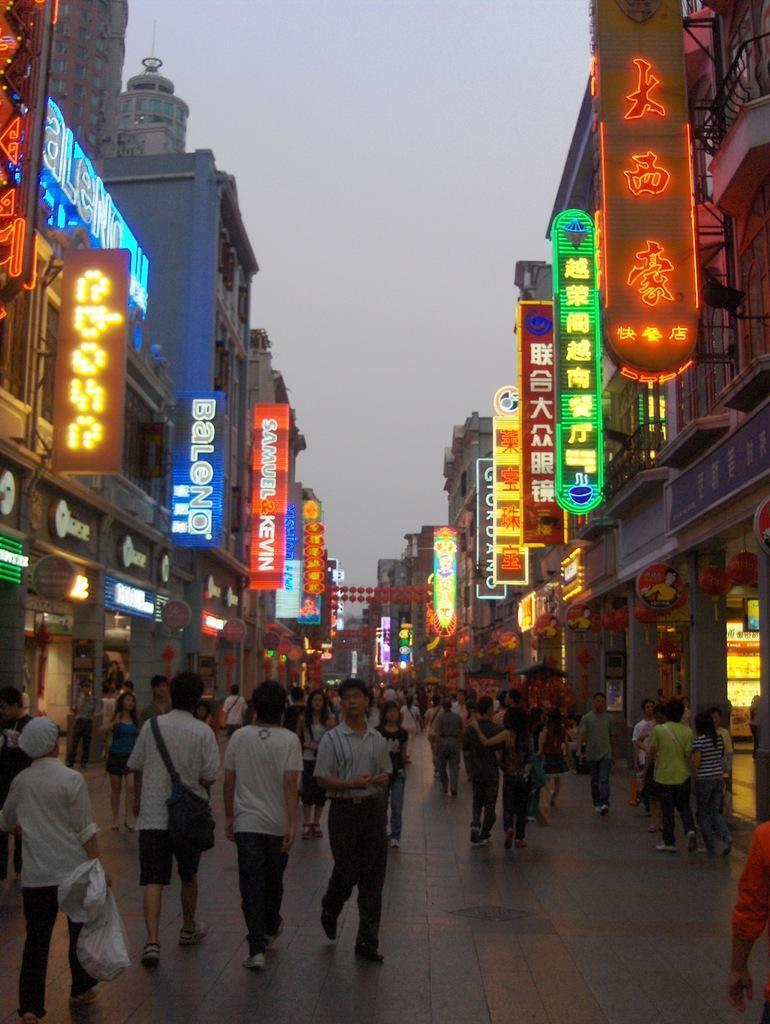Can you describe this image briefly? In the center of the image there are people walking on the road. On both right and left side of the image there are buildings and advertisement boards. In the background of the image there is sky. 